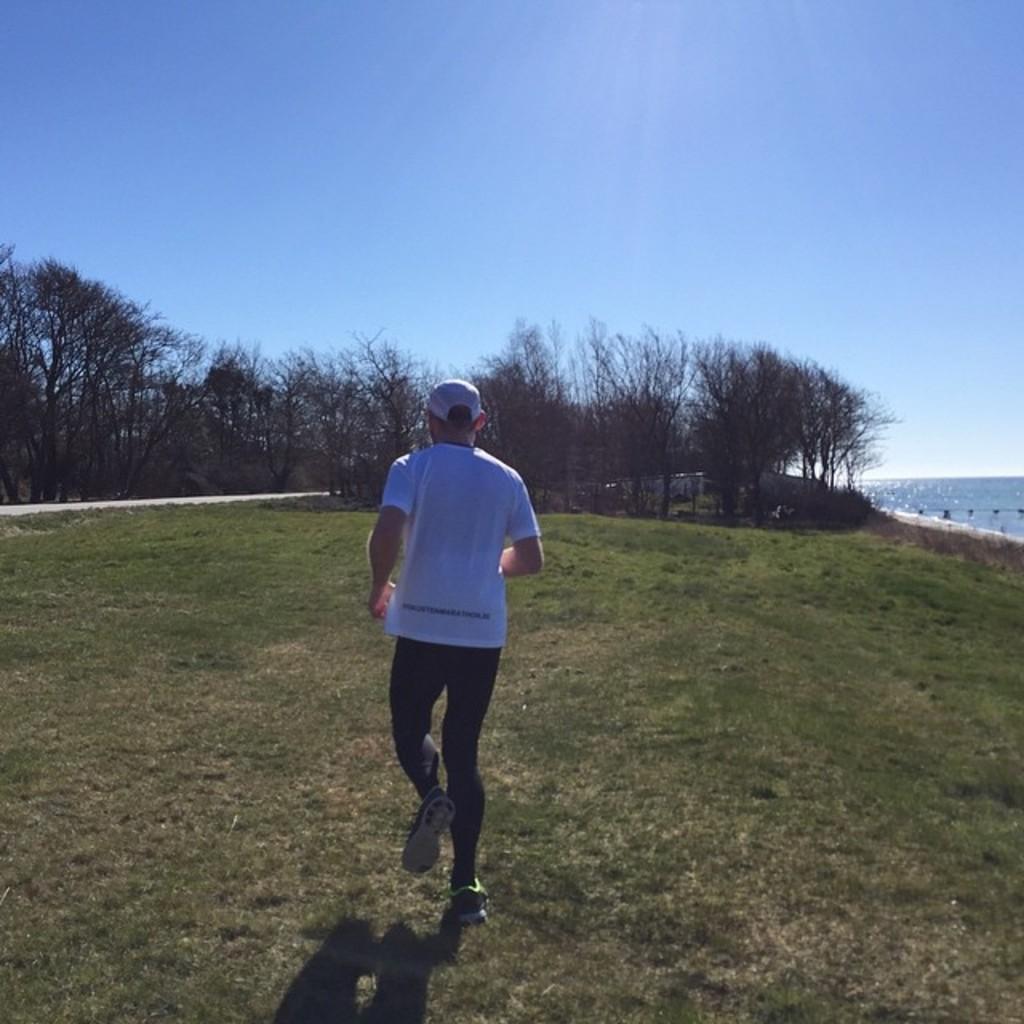Could you give a brief overview of what you see in this image? This is an outside view. Here I can see a man wearing white color t-shirt, cap on the head and running on the ground. In the background there are many trees and also I can see few houses. On the left side there is a road. On the right side there is an Ocean. At the top of the image I can see the sky. 